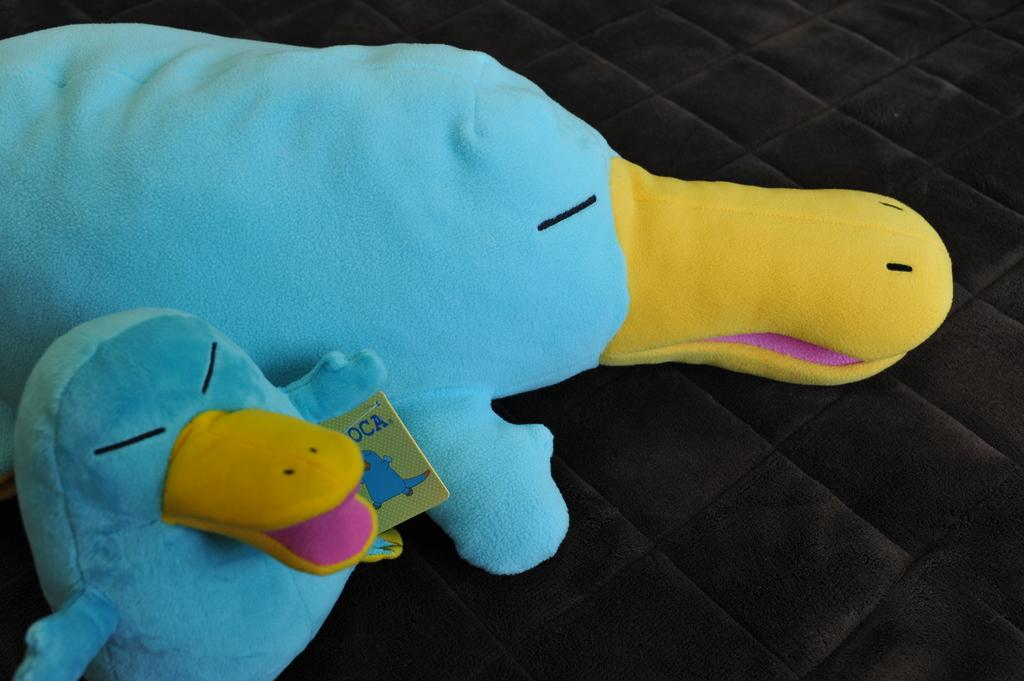How many toys are present in the image? There are two toys in the image. What colors are the toys' bodies? The toys have blue bodies. What feature do the toys have in common? The toys have yellow beaks. What is the color of the bed in the image? The bed in the image is brown in color. What type of cloth is used to make the toys' tongues? The toys do not have tongues, so there is no cloth used for their tongues. 